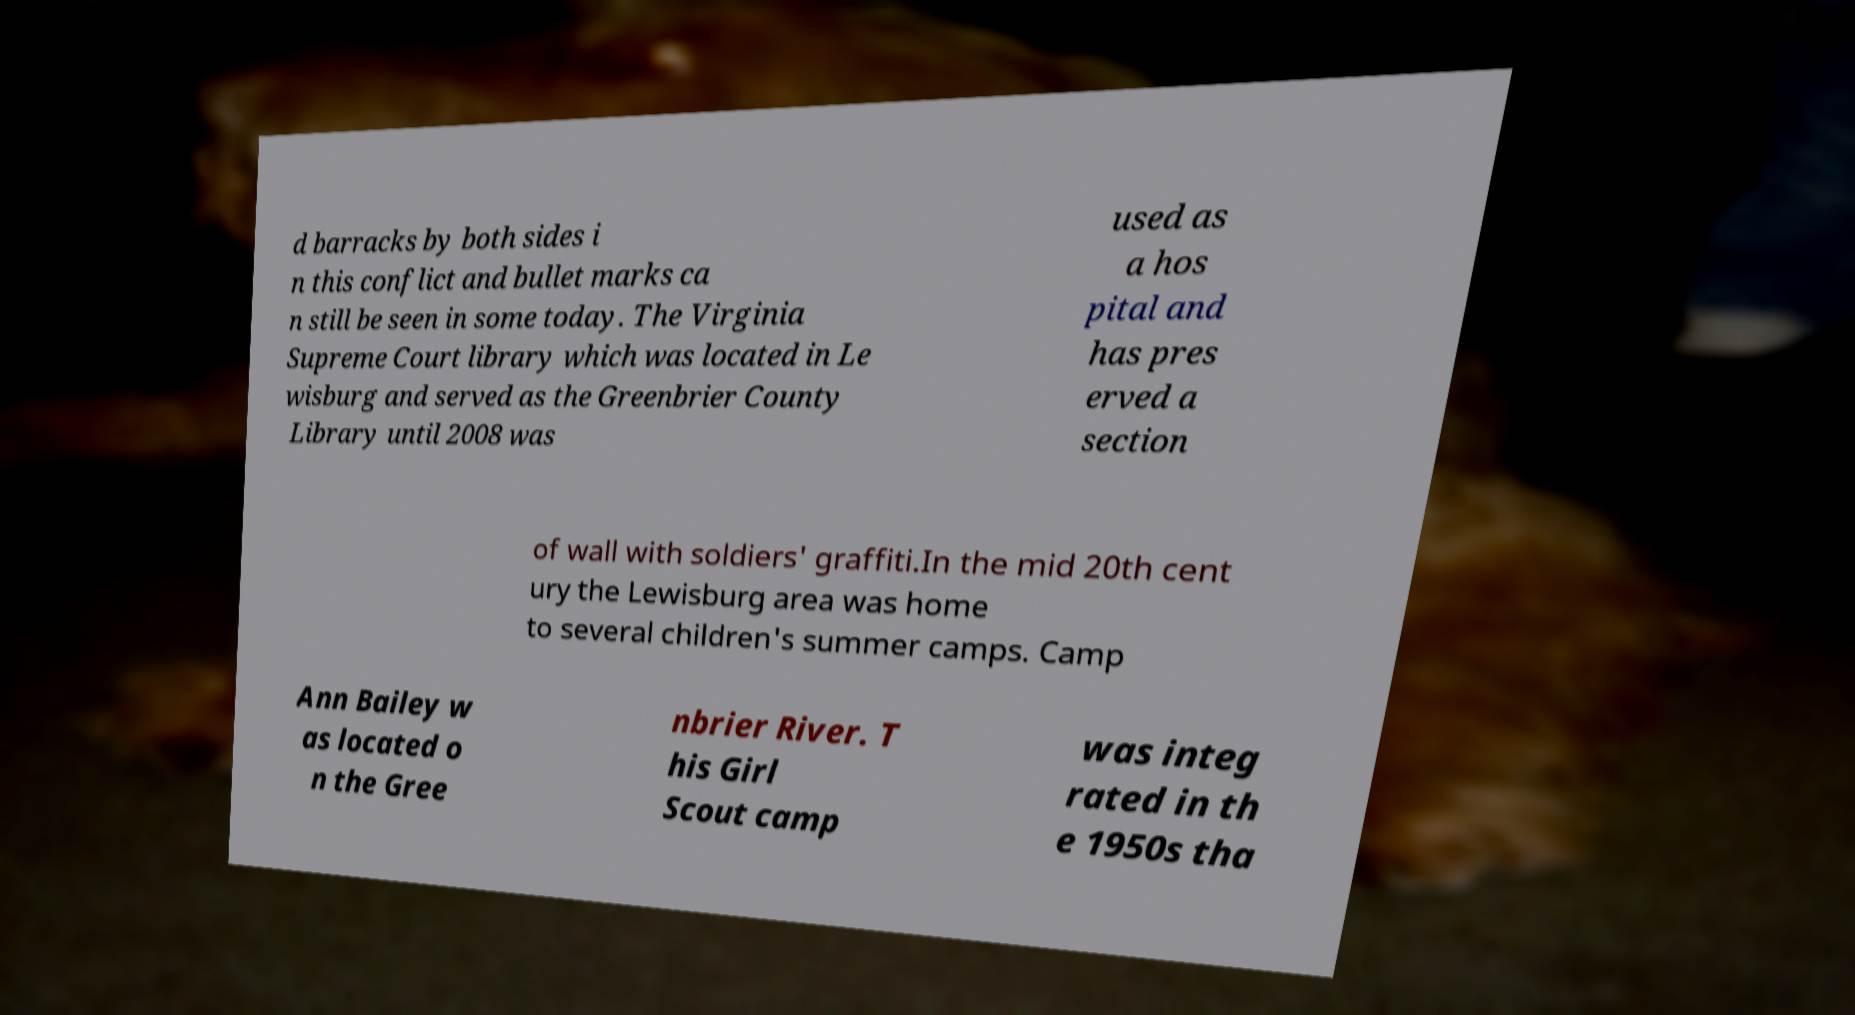Please identify and transcribe the text found in this image. d barracks by both sides i n this conflict and bullet marks ca n still be seen in some today. The Virginia Supreme Court library which was located in Le wisburg and served as the Greenbrier County Library until 2008 was used as a hos pital and has pres erved a section of wall with soldiers' graffiti.In the mid 20th cent ury the Lewisburg area was home to several children's summer camps. Camp Ann Bailey w as located o n the Gree nbrier River. T his Girl Scout camp was integ rated in th e 1950s tha 